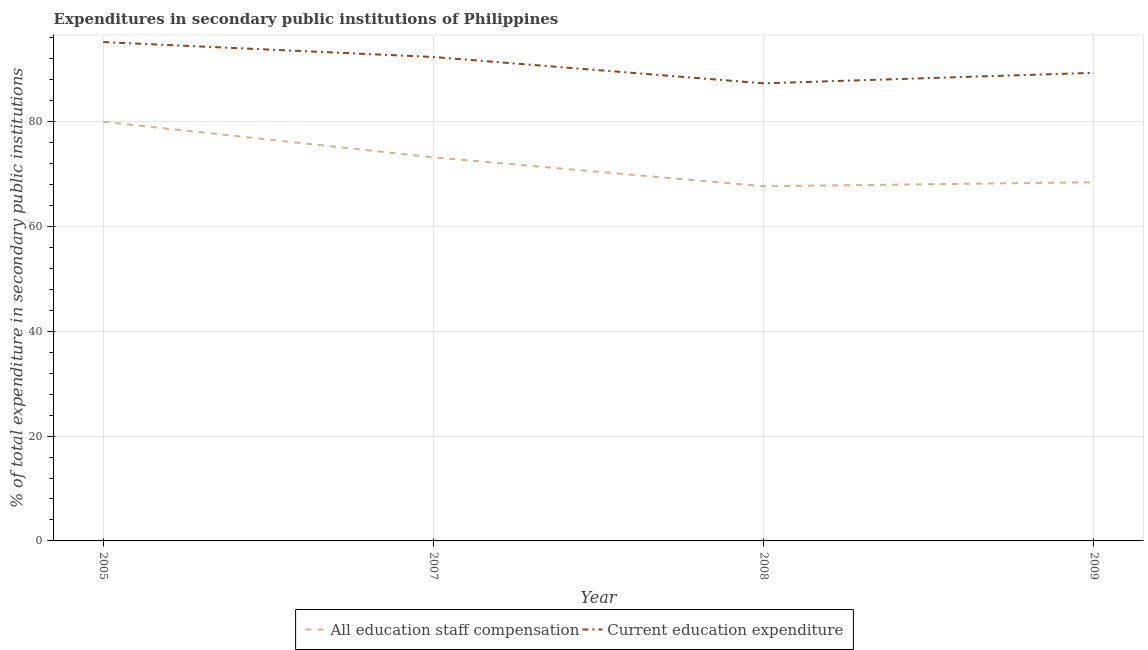What is the expenditure in education in 2005?
Provide a short and direct response. 95.18. Across all years, what is the maximum expenditure in staff compensation?
Provide a succinct answer. 79.98. Across all years, what is the minimum expenditure in staff compensation?
Keep it short and to the point. 67.67. In which year was the expenditure in staff compensation minimum?
Offer a very short reply. 2008. What is the total expenditure in staff compensation in the graph?
Offer a terse response. 289.26. What is the difference between the expenditure in education in 2007 and that in 2008?
Make the answer very short. 5.02. What is the difference between the expenditure in education in 2008 and the expenditure in staff compensation in 2005?
Give a very brief answer. 7.33. What is the average expenditure in staff compensation per year?
Offer a very short reply. 72.31. In the year 2008, what is the difference between the expenditure in education and expenditure in staff compensation?
Give a very brief answer. 19.64. In how many years, is the expenditure in education greater than 12 %?
Provide a succinct answer. 4. What is the ratio of the expenditure in staff compensation in 2005 to that in 2009?
Provide a short and direct response. 1.17. What is the difference between the highest and the second highest expenditure in staff compensation?
Provide a succinct answer. 6.79. What is the difference between the highest and the lowest expenditure in staff compensation?
Keep it short and to the point. 12.31. Is the expenditure in staff compensation strictly greater than the expenditure in education over the years?
Offer a very short reply. No. Is the expenditure in staff compensation strictly less than the expenditure in education over the years?
Provide a succinct answer. Yes. How many lines are there?
Make the answer very short. 2. How many years are there in the graph?
Your answer should be compact. 4. What is the difference between two consecutive major ticks on the Y-axis?
Your answer should be compact. 20. Does the graph contain any zero values?
Provide a succinct answer. No. Does the graph contain grids?
Your response must be concise. Yes. How are the legend labels stacked?
Your response must be concise. Horizontal. What is the title of the graph?
Offer a very short reply. Expenditures in secondary public institutions of Philippines. What is the label or title of the X-axis?
Ensure brevity in your answer.  Year. What is the label or title of the Y-axis?
Provide a succinct answer. % of total expenditure in secondary public institutions. What is the % of total expenditure in secondary public institutions in All education staff compensation in 2005?
Keep it short and to the point. 79.98. What is the % of total expenditure in secondary public institutions in Current education expenditure in 2005?
Keep it short and to the point. 95.18. What is the % of total expenditure in secondary public institutions of All education staff compensation in 2007?
Offer a very short reply. 73.18. What is the % of total expenditure in secondary public institutions in Current education expenditure in 2007?
Offer a very short reply. 92.33. What is the % of total expenditure in secondary public institutions of All education staff compensation in 2008?
Your answer should be compact. 67.67. What is the % of total expenditure in secondary public institutions of Current education expenditure in 2008?
Your response must be concise. 87.3. What is the % of total expenditure in secondary public institutions in All education staff compensation in 2009?
Offer a very short reply. 68.43. What is the % of total expenditure in secondary public institutions in Current education expenditure in 2009?
Your response must be concise. 89.31. Across all years, what is the maximum % of total expenditure in secondary public institutions in All education staff compensation?
Your answer should be very brief. 79.98. Across all years, what is the maximum % of total expenditure in secondary public institutions in Current education expenditure?
Make the answer very short. 95.18. Across all years, what is the minimum % of total expenditure in secondary public institutions in All education staff compensation?
Provide a short and direct response. 67.67. Across all years, what is the minimum % of total expenditure in secondary public institutions in Current education expenditure?
Your response must be concise. 87.3. What is the total % of total expenditure in secondary public institutions of All education staff compensation in the graph?
Your answer should be very brief. 289.26. What is the total % of total expenditure in secondary public institutions of Current education expenditure in the graph?
Your answer should be very brief. 364.11. What is the difference between the % of total expenditure in secondary public institutions in All education staff compensation in 2005 and that in 2007?
Keep it short and to the point. 6.79. What is the difference between the % of total expenditure in secondary public institutions of Current education expenditure in 2005 and that in 2007?
Provide a short and direct response. 2.85. What is the difference between the % of total expenditure in secondary public institutions in All education staff compensation in 2005 and that in 2008?
Provide a short and direct response. 12.31. What is the difference between the % of total expenditure in secondary public institutions in Current education expenditure in 2005 and that in 2008?
Make the answer very short. 7.87. What is the difference between the % of total expenditure in secondary public institutions of All education staff compensation in 2005 and that in 2009?
Your answer should be compact. 11.54. What is the difference between the % of total expenditure in secondary public institutions of Current education expenditure in 2005 and that in 2009?
Provide a succinct answer. 5.87. What is the difference between the % of total expenditure in secondary public institutions of All education staff compensation in 2007 and that in 2008?
Ensure brevity in your answer.  5.52. What is the difference between the % of total expenditure in secondary public institutions of Current education expenditure in 2007 and that in 2008?
Ensure brevity in your answer.  5.02. What is the difference between the % of total expenditure in secondary public institutions in All education staff compensation in 2007 and that in 2009?
Provide a succinct answer. 4.75. What is the difference between the % of total expenditure in secondary public institutions in Current education expenditure in 2007 and that in 2009?
Your answer should be very brief. 3.02. What is the difference between the % of total expenditure in secondary public institutions of All education staff compensation in 2008 and that in 2009?
Your answer should be compact. -0.77. What is the difference between the % of total expenditure in secondary public institutions of Current education expenditure in 2008 and that in 2009?
Your response must be concise. -2. What is the difference between the % of total expenditure in secondary public institutions of All education staff compensation in 2005 and the % of total expenditure in secondary public institutions of Current education expenditure in 2007?
Keep it short and to the point. -12.35. What is the difference between the % of total expenditure in secondary public institutions in All education staff compensation in 2005 and the % of total expenditure in secondary public institutions in Current education expenditure in 2008?
Your answer should be compact. -7.33. What is the difference between the % of total expenditure in secondary public institutions of All education staff compensation in 2005 and the % of total expenditure in secondary public institutions of Current education expenditure in 2009?
Provide a succinct answer. -9.33. What is the difference between the % of total expenditure in secondary public institutions in All education staff compensation in 2007 and the % of total expenditure in secondary public institutions in Current education expenditure in 2008?
Offer a very short reply. -14.12. What is the difference between the % of total expenditure in secondary public institutions in All education staff compensation in 2007 and the % of total expenditure in secondary public institutions in Current education expenditure in 2009?
Make the answer very short. -16.12. What is the difference between the % of total expenditure in secondary public institutions in All education staff compensation in 2008 and the % of total expenditure in secondary public institutions in Current education expenditure in 2009?
Your response must be concise. -21.64. What is the average % of total expenditure in secondary public institutions of All education staff compensation per year?
Give a very brief answer. 72.31. What is the average % of total expenditure in secondary public institutions of Current education expenditure per year?
Your response must be concise. 91.03. In the year 2005, what is the difference between the % of total expenditure in secondary public institutions in All education staff compensation and % of total expenditure in secondary public institutions in Current education expenditure?
Offer a terse response. -15.2. In the year 2007, what is the difference between the % of total expenditure in secondary public institutions of All education staff compensation and % of total expenditure in secondary public institutions of Current education expenditure?
Your response must be concise. -19.14. In the year 2008, what is the difference between the % of total expenditure in secondary public institutions in All education staff compensation and % of total expenditure in secondary public institutions in Current education expenditure?
Offer a very short reply. -19.64. In the year 2009, what is the difference between the % of total expenditure in secondary public institutions of All education staff compensation and % of total expenditure in secondary public institutions of Current education expenditure?
Make the answer very short. -20.87. What is the ratio of the % of total expenditure in secondary public institutions of All education staff compensation in 2005 to that in 2007?
Offer a very short reply. 1.09. What is the ratio of the % of total expenditure in secondary public institutions of Current education expenditure in 2005 to that in 2007?
Offer a very short reply. 1.03. What is the ratio of the % of total expenditure in secondary public institutions of All education staff compensation in 2005 to that in 2008?
Offer a very short reply. 1.18. What is the ratio of the % of total expenditure in secondary public institutions of Current education expenditure in 2005 to that in 2008?
Give a very brief answer. 1.09. What is the ratio of the % of total expenditure in secondary public institutions in All education staff compensation in 2005 to that in 2009?
Provide a short and direct response. 1.17. What is the ratio of the % of total expenditure in secondary public institutions in Current education expenditure in 2005 to that in 2009?
Keep it short and to the point. 1.07. What is the ratio of the % of total expenditure in secondary public institutions of All education staff compensation in 2007 to that in 2008?
Ensure brevity in your answer.  1.08. What is the ratio of the % of total expenditure in secondary public institutions of Current education expenditure in 2007 to that in 2008?
Offer a very short reply. 1.06. What is the ratio of the % of total expenditure in secondary public institutions in All education staff compensation in 2007 to that in 2009?
Ensure brevity in your answer.  1.07. What is the ratio of the % of total expenditure in secondary public institutions of Current education expenditure in 2007 to that in 2009?
Give a very brief answer. 1.03. What is the ratio of the % of total expenditure in secondary public institutions in All education staff compensation in 2008 to that in 2009?
Make the answer very short. 0.99. What is the ratio of the % of total expenditure in secondary public institutions in Current education expenditure in 2008 to that in 2009?
Give a very brief answer. 0.98. What is the difference between the highest and the second highest % of total expenditure in secondary public institutions in All education staff compensation?
Offer a terse response. 6.79. What is the difference between the highest and the second highest % of total expenditure in secondary public institutions of Current education expenditure?
Ensure brevity in your answer.  2.85. What is the difference between the highest and the lowest % of total expenditure in secondary public institutions of All education staff compensation?
Offer a very short reply. 12.31. What is the difference between the highest and the lowest % of total expenditure in secondary public institutions of Current education expenditure?
Offer a terse response. 7.87. 